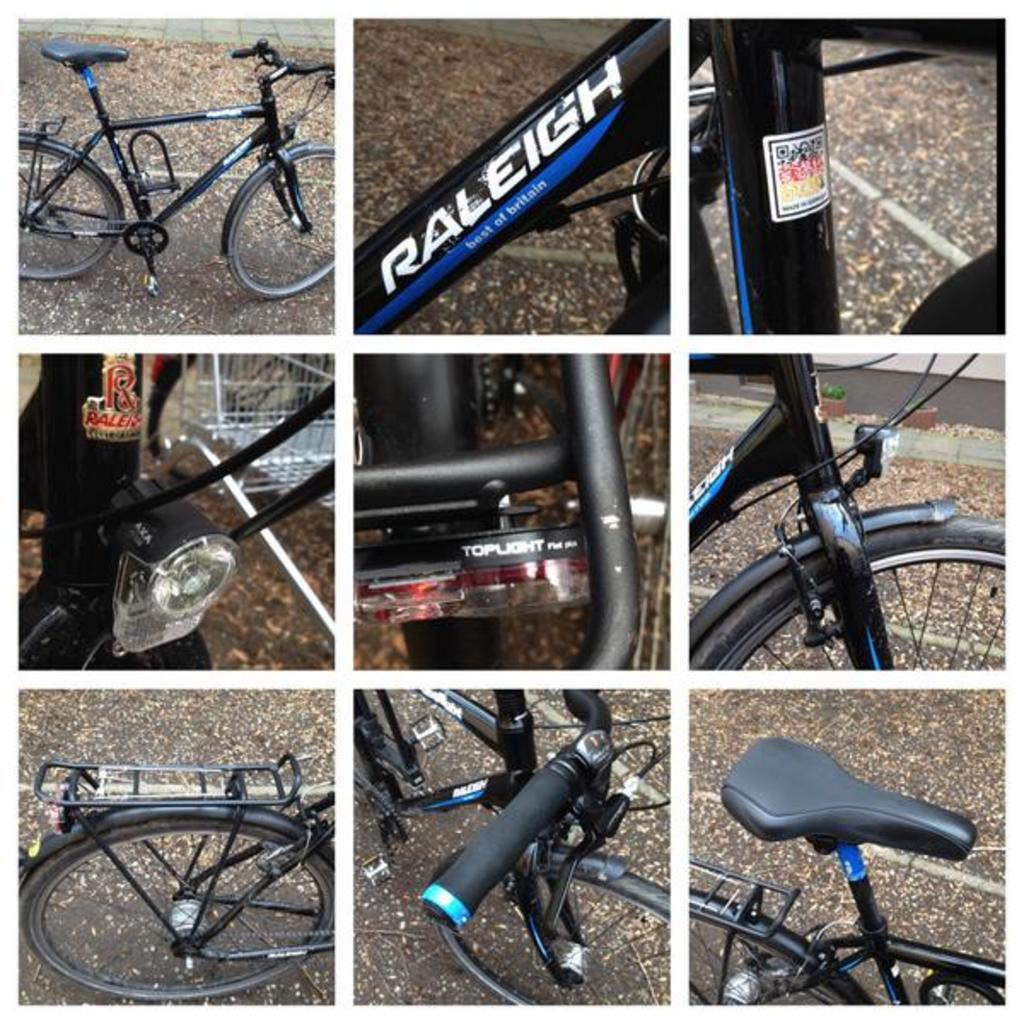What type of image is being described? The image is an edited image. How is the edited image composed? The image consists of nine smaller images. What do the smaller images depict? Each smaller image shows a different part of a bicycle. Can you see any goats in the yard near the ocean in the image? There are no goats, yards, or oceans present in the image; it consists of nine smaller images of a bicycle. 